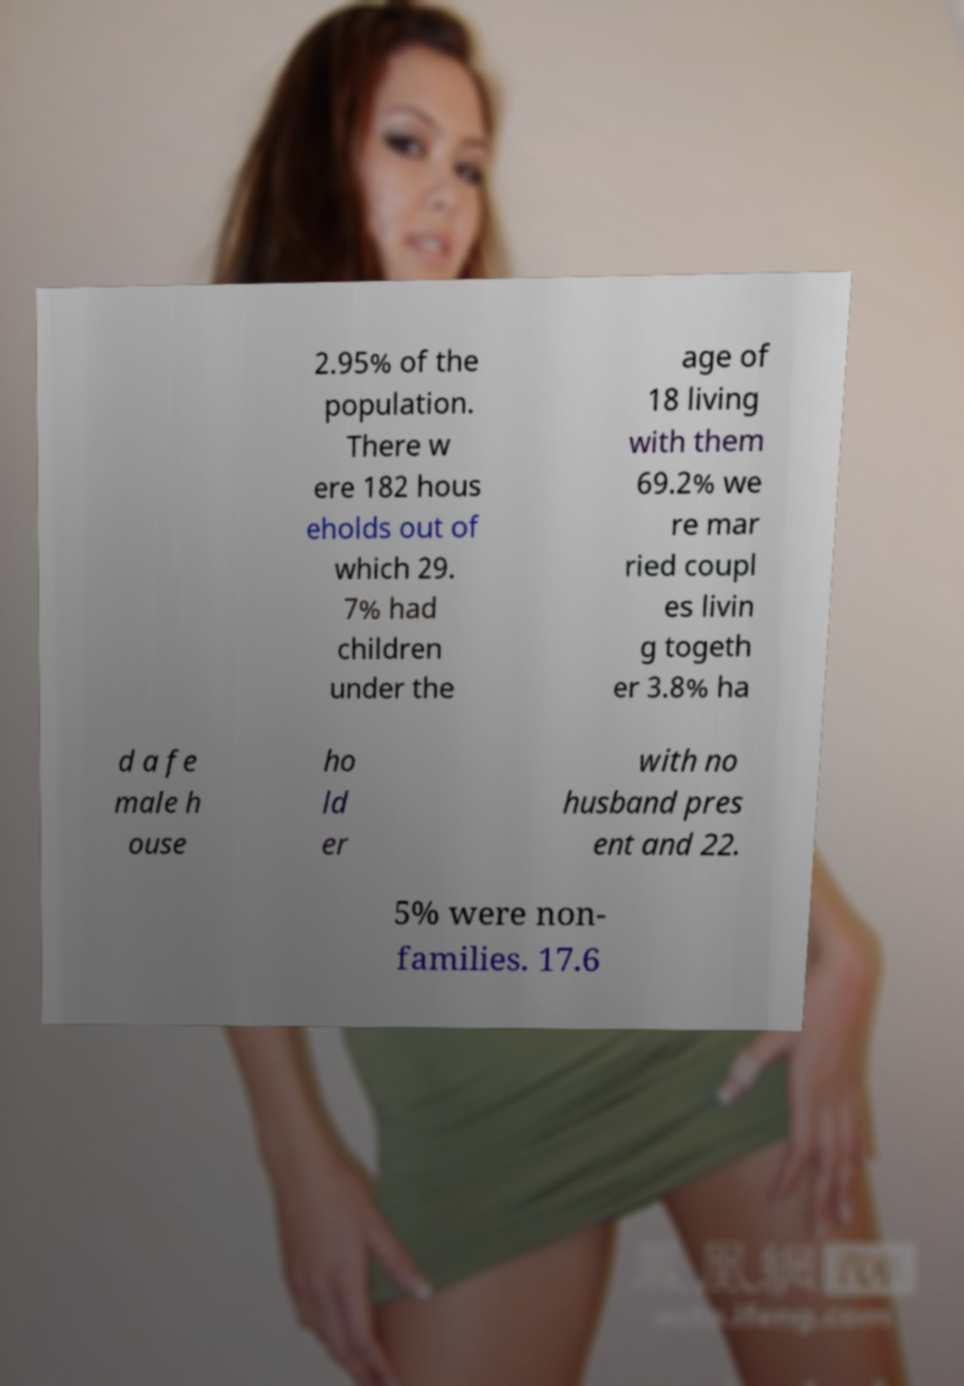What messages or text are displayed in this image? I need them in a readable, typed format. 2.95% of the population. There w ere 182 hous eholds out of which 29. 7% had children under the age of 18 living with them 69.2% we re mar ried coupl es livin g togeth er 3.8% ha d a fe male h ouse ho ld er with no husband pres ent and 22. 5% were non- families. 17.6 